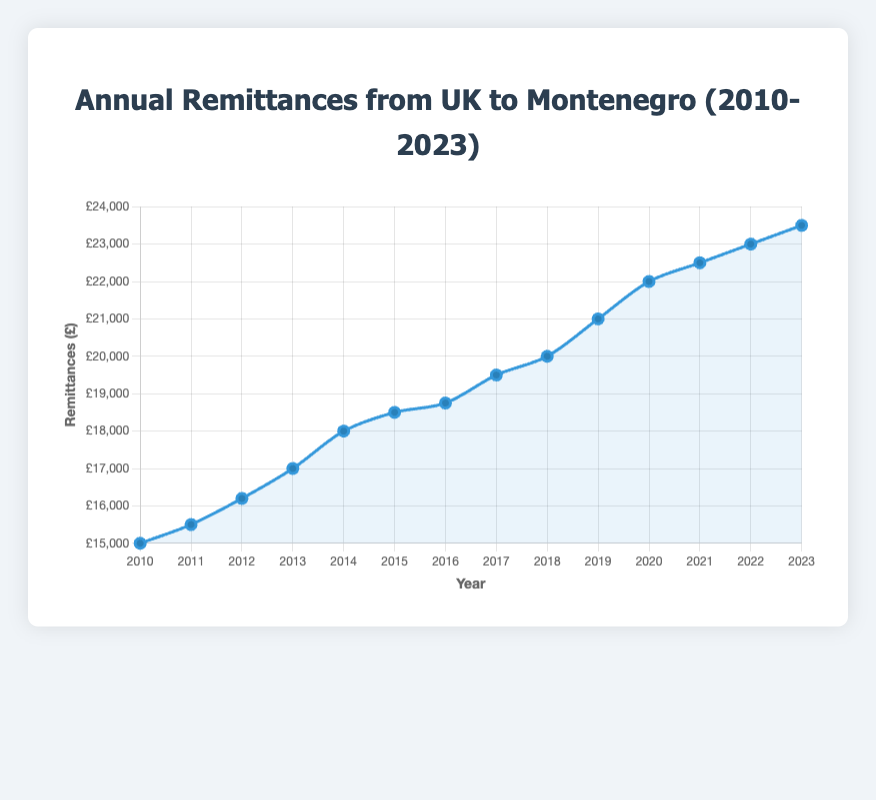What is the overall trend in remittances from 2010 to 2023? By observing the plot, we see that the remittances from the UK to Montenegro have steadily increased each year from 2010 to 2023. The line slopes upward throughout the entire period.
Answer: Steadily increasing Which year saw the largest increase in remittances compared to the previous year? By examining the steepest slopes between two consecutive points on the plot, we note that the largest increase is from 2012 to 2013. Remittances increased from £16,200 in 2012 to £17,000 in 2013, a difference of £800.
Answer: 2013 By how much did the remittances increase from 2010 to 2023? To find this value, subtract the remittances in 2010 from the remittances in 2023: £23,500 - £15,000 = £8,500.
Answer: £8,500 What is the average remittance sent annually over the period from 2010 to 2023? First, sum all annual remittances: £15,000 + £15,500 + £16,200 + £17,000 + £18,000 + £18,500 + £18,750 + £19,500 + £20,000 + £21,000 + £22,000 + £22,500 + £23,000 + £23,500 = £270,450. Then, divide this sum by the number of years (14): £270,450 / 14 ≈ £19,318
Answer: £19,318 In which year does the remittances cross £20,000 for the first time? Observing the line plot, it becomes evident that remittances exceed £20,000 for the first time in 2019.
Answer: 2019 How do the remittances in 2014 compare with those in 2022? By comparing the values on the plot for the years 2014 and 2022, we see that remittances in 2014 were £18,000, while in 2022, they were £23,000. Therefore, remittances in 2022 were £5,000 higher than in 2014.
Answer: £5,000 higher What is the average annual increase in remittances over the period from 2010 to 2023? Find the total increase in remittances (£8,500 from 2010 to 2023) and divide it by the number of intervals (2023-2010 = 13 years). Therefore, £8,500 / 13 ≈ £654 per year.
Answer: £654 per year What was the total remittances sent from 2016 to 2020? Sum the annual remittances from 2016 to 2020: £18,750 + £19,500 + £20,000 + £21,000 + £22,000 = £101,250.
Answer: £101,250 Compare the remittances sent in the first five years (2010-2014) with the last five years (2019-2023). Which period saw higher total remittances? Sum the remittances from 2010 to 2014: £15,000 + £15,500 + £16,200 + £17,000 + £18,000 = £81,700. And from 2019 to 2023: £21,000 + £22,000 + £22,500 + £23,000 + £23,500 = £112,000. Comparing these, the total remittances in the last five years are higher by £112,000 - £81,700 = £30,300.
Answer: Last five years What is the median value of the remittances during the period 2010-2023? List the remittances in order: £15,000, £15,500, £16,200, £17,000, £18,000, £18,500, £18,750, £19,500, £20,000, £21,000, £22,000, £22,500, £23,000, £23,500. The median is the middle value, which is the average of the 7th and 8th values: (£18,750 + £19,500) / 2 = £19,125.
Answer: £19,125 